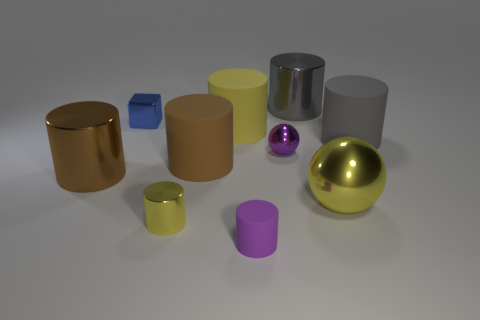Subtract all yellow cylinders. How many cylinders are left? 5 Subtract all large yellow rubber cylinders. How many cylinders are left? 6 Subtract all purple cylinders. Subtract all red spheres. How many cylinders are left? 6 Subtract all balls. How many objects are left? 8 Subtract all tiny blue cubes. Subtract all big yellow matte cylinders. How many objects are left? 8 Add 1 cylinders. How many cylinders are left? 8 Add 8 tiny purple metal things. How many tiny purple metal things exist? 9 Subtract 0 cyan cylinders. How many objects are left? 10 